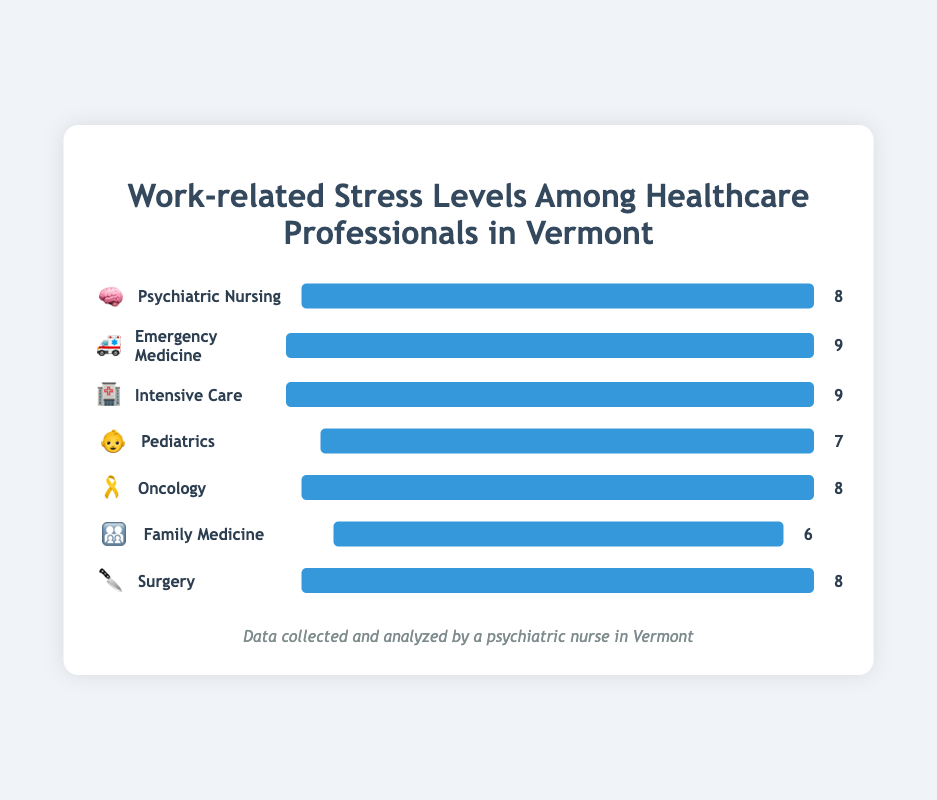Which specialty has the highest stress level? The highest stress level is 9. Both Emergency Medicine and Intensive Care have this level.
Answer: Emergency Medicine and Intensive Care How many specialties have a stress level of 8? By counting the specialties with a stress level of 8, we find that Psychiatric Nursing, Oncology, and Surgery all have this level.
Answer: 3 Which specialty has the least stress level and what is it? Family Medicine has the least stress level, which is 6.
Answer: Family Medicine, 6 What is the average stress level of all specialties? Sum of all stress levels (8 + 9 + 9 + 7 + 8 + 6 + 8) = 55. There are 7 specialties, so the average stress level = 55 / 7.
Answer: 7.86 What are the differences in stress levels between Pediatrics and Surgery? Pediatrics has a stress level of 7, while Surgery has a stress level of 8. The difference is 8 - 7.
Answer: 1 Which specialties have a stress level equal to 8? The specialties with a stress level of 8 are Psychiatric Nursing, Oncology, and Surgery.
Answer: Psychiatric Nursing, Oncology, Surgery Comparing Oncology and Family Medicine, which one has a higher stress level? Oncology has a stress level of 8, while Family Medicine has a stress level of 6. So, Oncology has a higher stress level.
Answer: Oncology What’s the total stress level for Emergency Medicine and Intensive Care combined? Both Emergency Medicine and Intensive Care have a stress level of 9 each. Combined stress level = 9 + 9.
Answer: 18 Rank the specialties from highest to lowest stress level. The highest stress level is 9 (Emergency Medicine, Intensive Care), followed by 8 (Psychiatric Nursing, Oncology, Surgery), then 7 (Pediatrics), and the lowest is 6 (Family Medicine). So, the ranking is: Emergency Medicine, Intensive Care, Psychiatric Nursing, Oncology, Surgery, Pediatrics, Family Medicine.
Answer: Emergency Medicine, Intensive Care, Psychiatric Nursing, Oncology, Surgery, Pediatrics, Family Medicine 